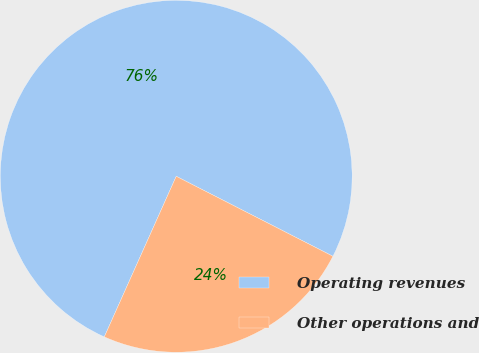Convert chart to OTSL. <chart><loc_0><loc_0><loc_500><loc_500><pie_chart><fcel>Operating revenues<fcel>Other operations and<nl><fcel>75.81%<fcel>24.19%<nl></chart> 